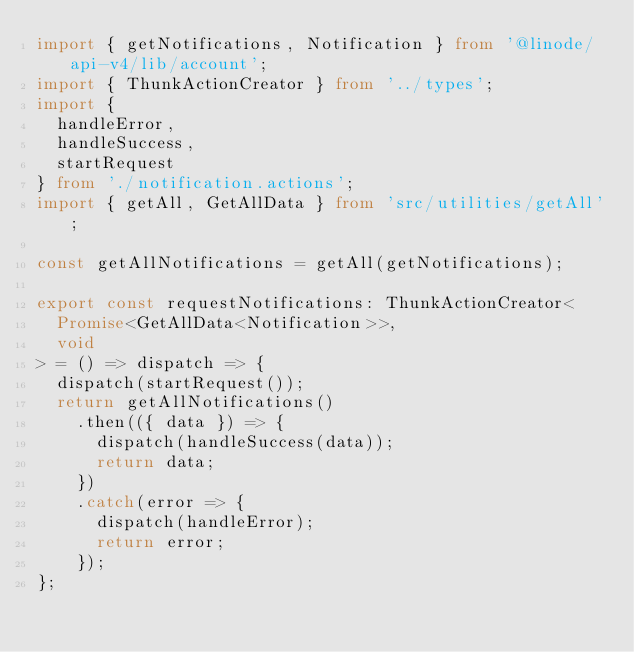<code> <loc_0><loc_0><loc_500><loc_500><_TypeScript_>import { getNotifications, Notification } from '@linode/api-v4/lib/account';
import { ThunkActionCreator } from '../types';
import {
  handleError,
  handleSuccess,
  startRequest
} from './notification.actions';
import { getAll, GetAllData } from 'src/utilities/getAll';

const getAllNotifications = getAll(getNotifications);

export const requestNotifications: ThunkActionCreator<
  Promise<GetAllData<Notification>>,
  void
> = () => dispatch => {
  dispatch(startRequest());
  return getAllNotifications()
    .then(({ data }) => {
      dispatch(handleSuccess(data));
      return data;
    })
    .catch(error => {
      dispatch(handleError);
      return error;
    });
};
</code> 